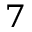<formula> <loc_0><loc_0><loc_500><loc_500>^ { 7 }</formula> 